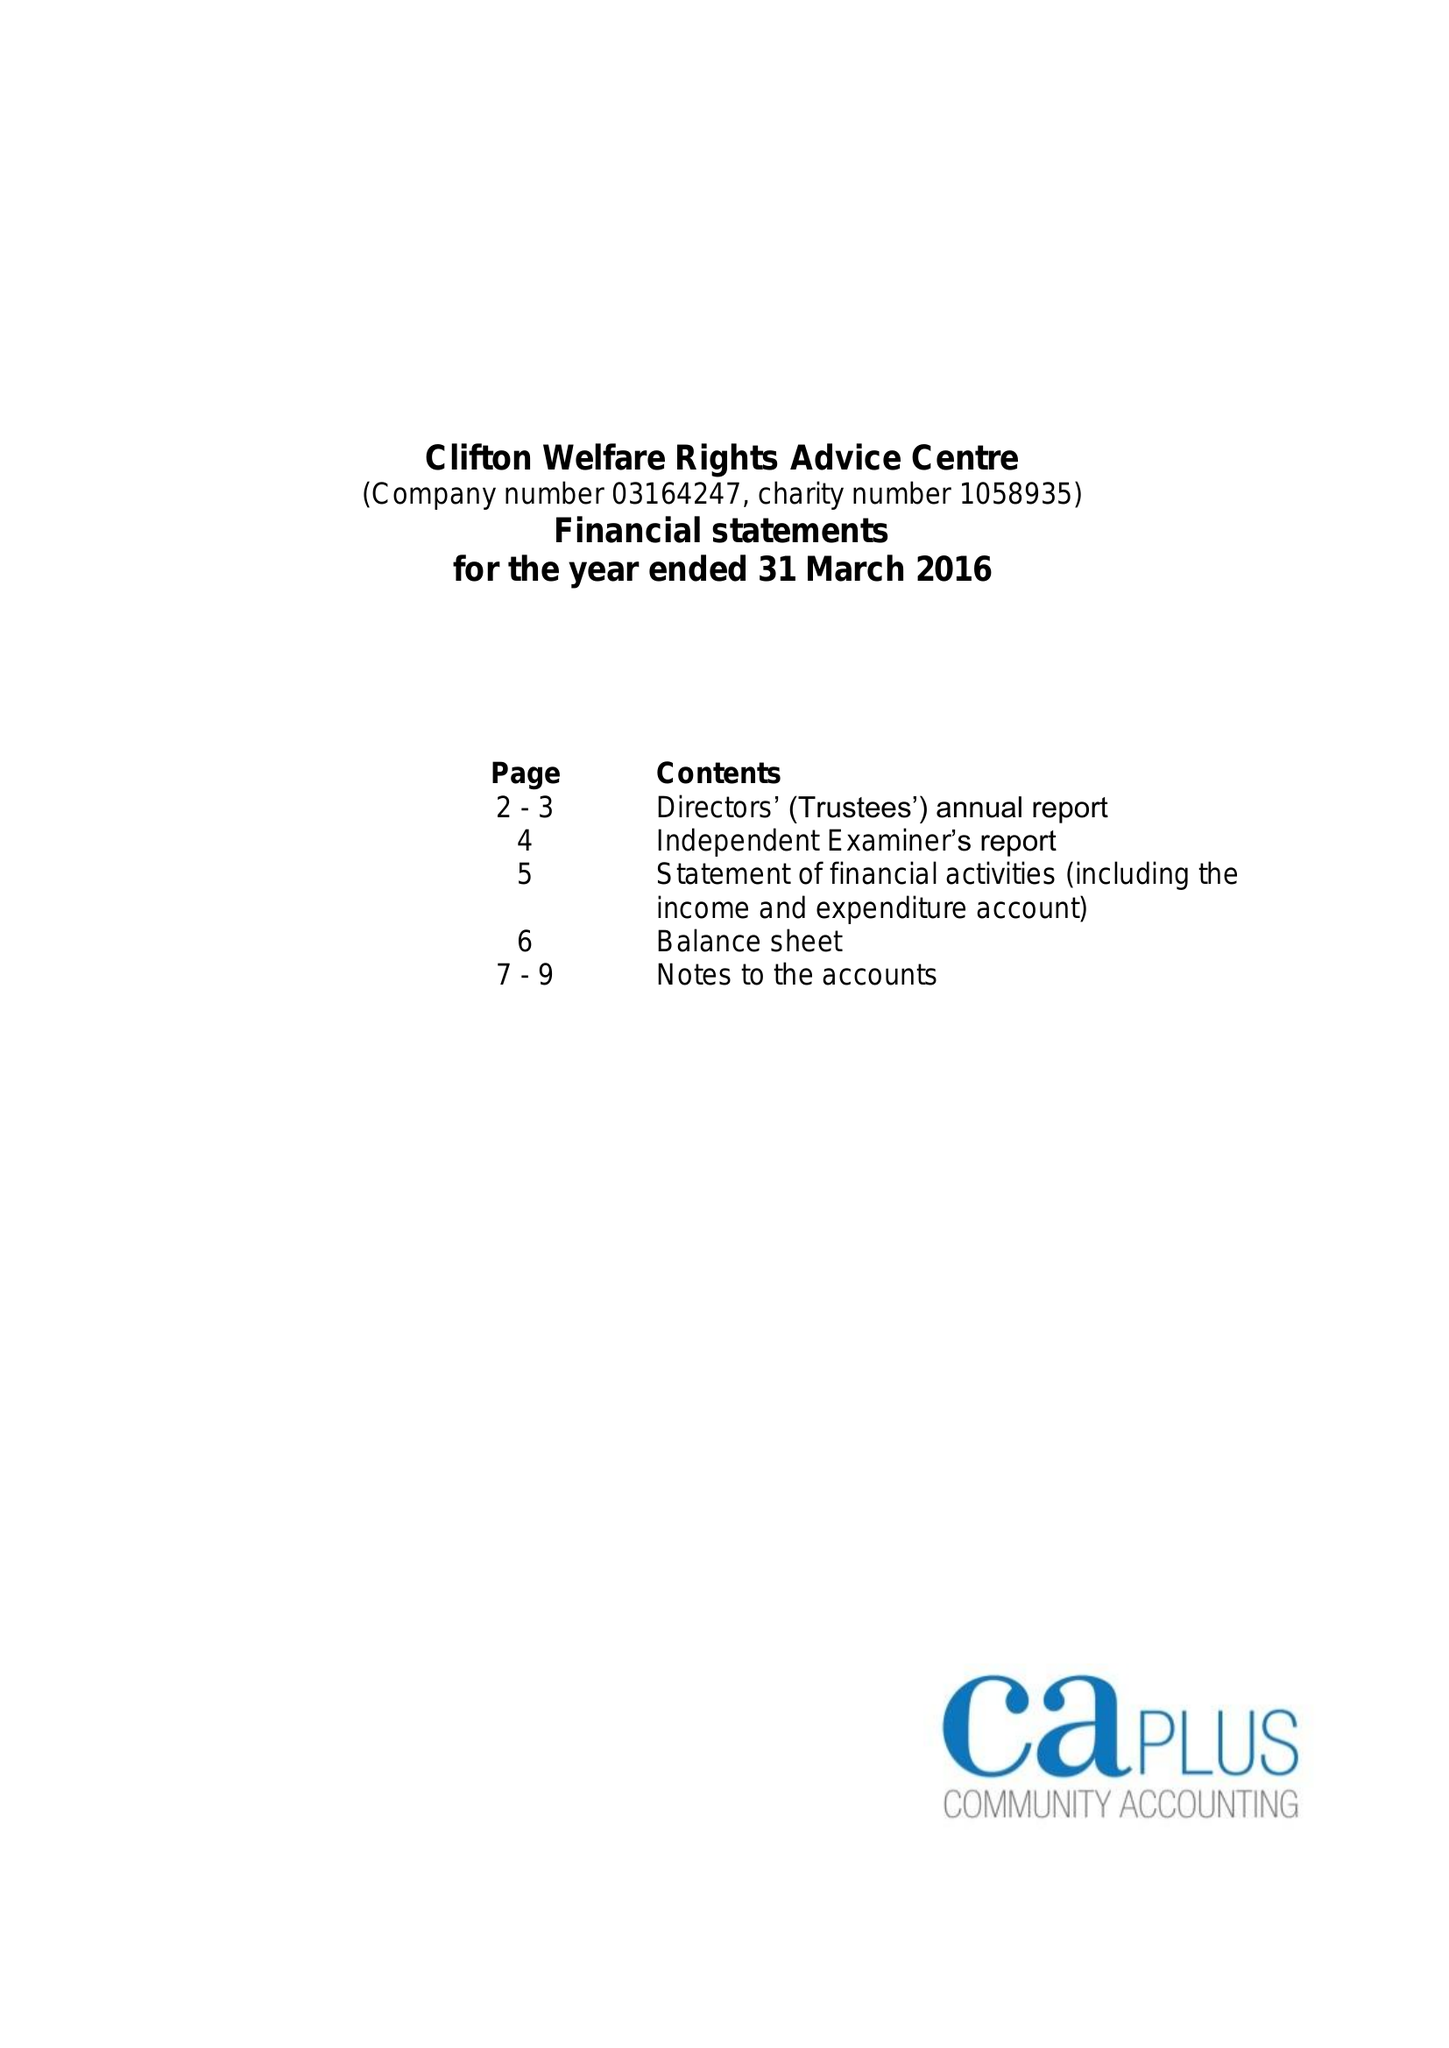What is the value for the address__street_line?
Answer the question using a single word or phrase. SOUTHCHURCH DRIVE 